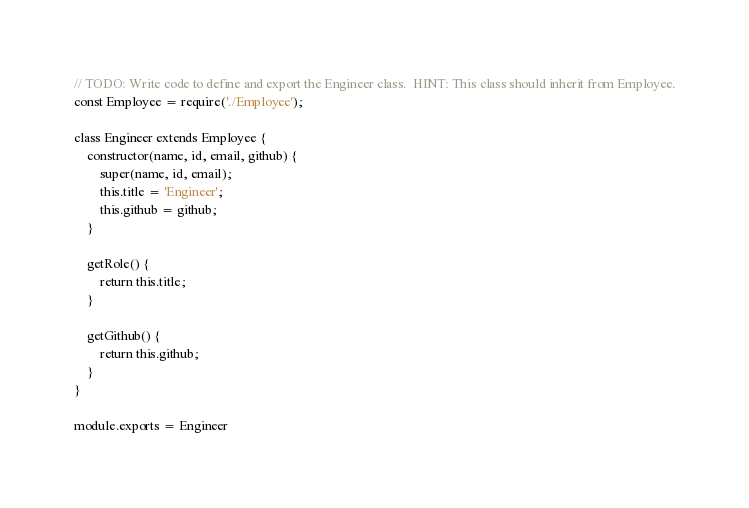<code> <loc_0><loc_0><loc_500><loc_500><_JavaScript_>// TODO: Write code to define and export the Engineer class.  HINT: This class should inherit from Employee.
const Employee = require('./Employee');

class Engineer extends Employee {
    constructor(name, id, email, github) {
        super(name, id, email);
        this.title = 'Engineer';
        this.github = github;
    }

    getRole() {
        return this.title;
    }

    getGithub() {
        return this.github;
    }
}

module.exports = Engineer</code> 